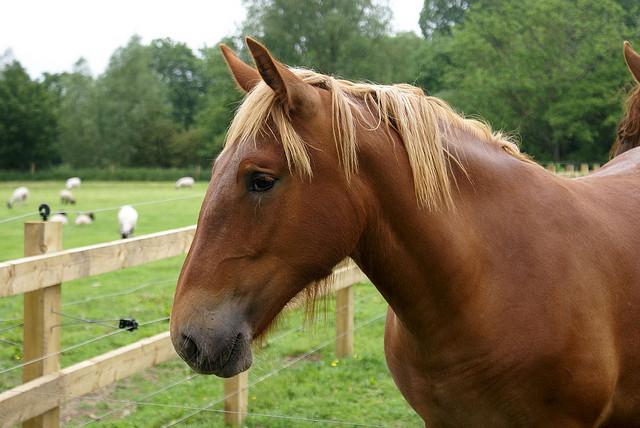What is the horse doing?
Quick response, please. Standing. Where is the fence?
Concise answer only. Behind horse. Do all of the animals in the picture graze?
Short answer required. Yes. 